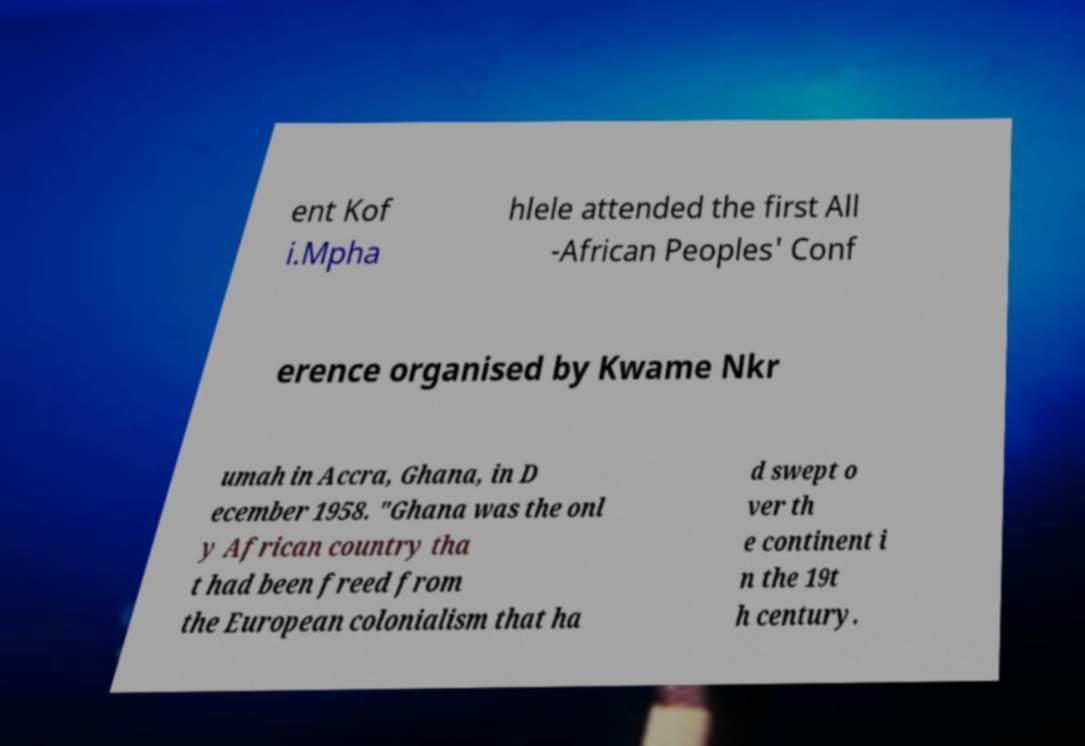Could you extract and type out the text from this image? ent Kof i.Mpha hlele attended the first All -African Peoples' Conf erence organised by Kwame Nkr umah in Accra, Ghana, in D ecember 1958. "Ghana was the onl y African country tha t had been freed from the European colonialism that ha d swept o ver th e continent i n the 19t h century. 